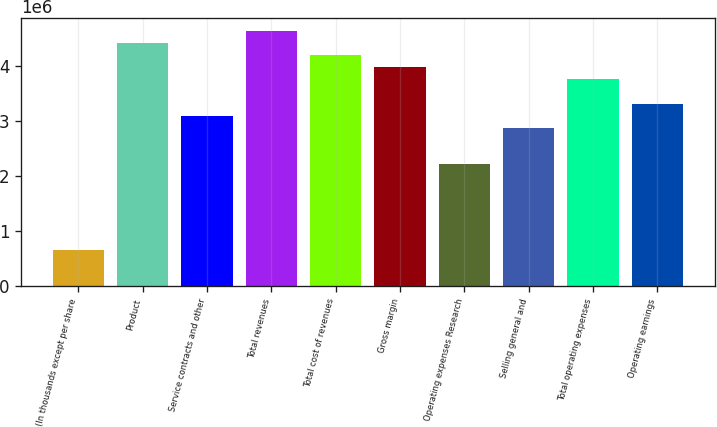<chart> <loc_0><loc_0><loc_500><loc_500><bar_chart><fcel>(In thousands except per share<fcel>Product<fcel>Service contracts and other<fcel>Total revenues<fcel>Total cost of revenues<fcel>Gross margin<fcel>Operating expenses Research<fcel>Selling general and<fcel>Total operating expenses<fcel>Operating earnings<nl><fcel>664218<fcel>4.42812e+06<fcel>3.09968e+06<fcel>4.64953e+06<fcel>4.20671e+06<fcel>3.98531e+06<fcel>2.21406e+06<fcel>2.87828e+06<fcel>3.7639e+06<fcel>3.32109e+06<nl></chart> 